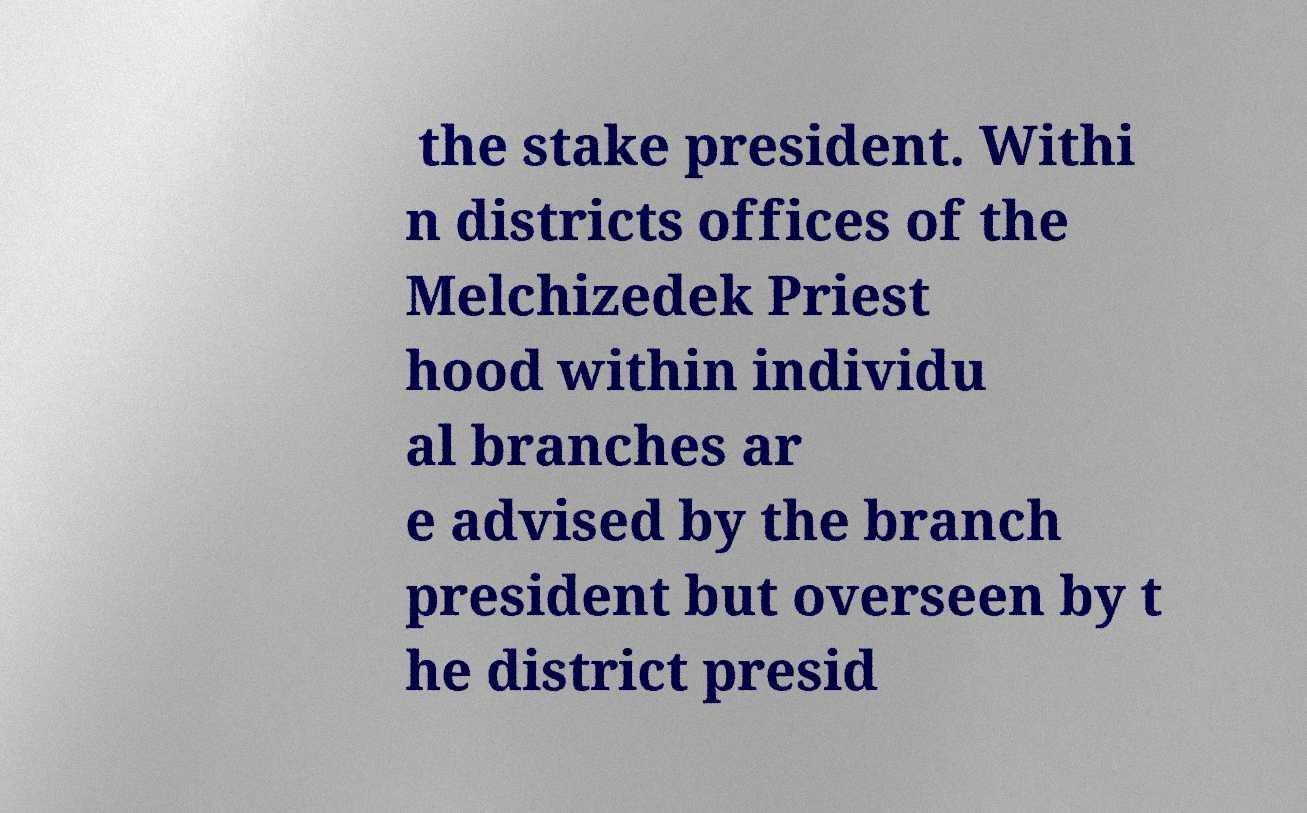For documentation purposes, I need the text within this image transcribed. Could you provide that? the stake president. Withi n districts offices of the Melchizedek Priest hood within individu al branches ar e advised by the branch president but overseen by t he district presid 